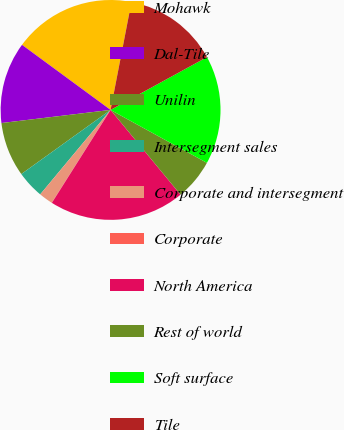Convert chart to OTSL. <chart><loc_0><loc_0><loc_500><loc_500><pie_chart><fcel>Mohawk<fcel>Dal-Tile<fcel>Unilin<fcel>Intersegment sales<fcel>Corporate and intersegment<fcel>Corporate<fcel>North America<fcel>Rest of world<fcel>Soft surface<fcel>Tile<nl><fcel>17.96%<fcel>11.99%<fcel>8.01%<fcel>4.03%<fcel>2.04%<fcel>0.05%<fcel>19.95%<fcel>6.02%<fcel>15.97%<fcel>13.98%<nl></chart> 